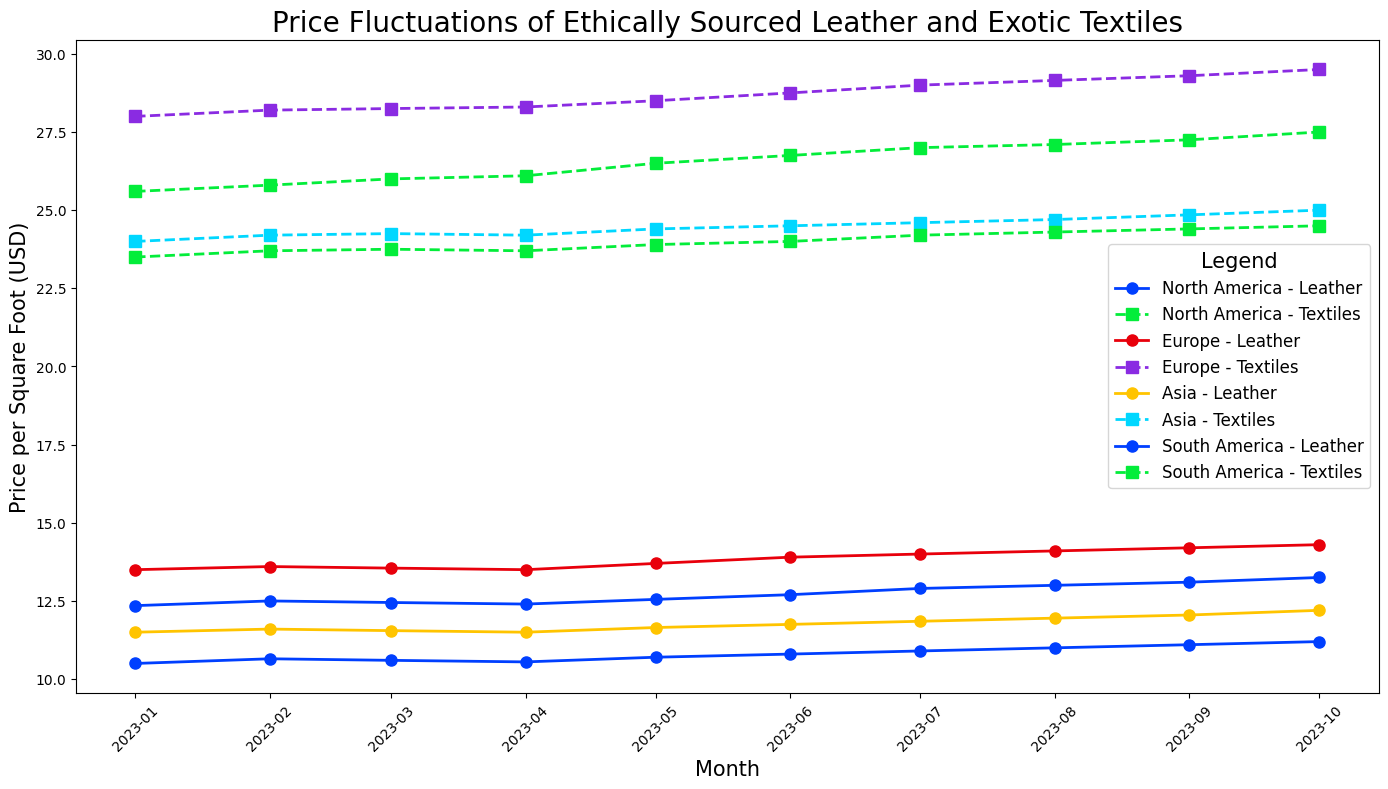Which region has the highest price for exotic textiles in October 2023? First, look at the data points in October 2023 for all regions for exotic textiles prices. Then, compare the values. Europe has the highest price of 29.50 USD per square foot.
Answer: Europe How much did the price of ethically sourced leather increase from January to October 2023 in North America? Identify the prices for January and October 2023 in North America for ethically sourced leather. Calculate the difference: 13.25 - 12.35 = 0.90 USD.
Answer: 0.90 USD Which region showed the most steady increase in the price of exotic textiles over the period? Examine the trend lines for exotic textiles in all regions and identify which one shows a consistent upward trend without any declines. Europe has a steady and consistent increase.
Answer: Europe On average, which region experienced the highest price for ethically sourced leather over the 10 months? Calculate the average price for each region by summing monthly prices and dividing by 10:
- North America: (12.35 + 12.50 + ... + 13.25) / 10 = 12.685 USD
- Europe: (13.50 + 13.60 + ... + 14.30) / 10 = 13.935 USD
- Asia: (11.50 + 11.60 + ... + 12.20) / 10 = 11.815 USD
- South America: (10.50 + 10.65 + ... + 11.20) / 10 = 10.82 USD
Europe has the highest average price of 13.935 USD.
Answer: Europe Did the price of exotic textiles in South America ever surpass the price of ethically sourced leather in the same region? Compare the monthly prices of exotic textiles with ethically sourced leather in South America. In every month, the price of exotic textiles is higher than ethically sourced leather.
Answer: Yes In which month did North America see the largest monthly increase in ethically sourced leather prices? Calculate the monthly changes and identify the month with the largest increase:
- February: 12.50 - 12.35 = 0.15 USD
- May: 12.55 - 12.40 = 0.15 USD
- June: 12.70 - 12.55 = 0.15 USD
- July: 12.90 - 12.70 = 0.20 USD
- October: 13.25 - 13.10 = 0.15 USD
July has the largest monthly increase of 0.20 USD.
Answer: July What was the combined price of exotic textiles and ethically sourced leather in Asia in August 2023? Add the prices of exotic textiles and ethically sourced leather for Asia in August 2023: 24.70 + 11.95 = 36.65 USD.
Answer: 36.65 USD Which month had the lowest price for exotic textiles in any region, and which region was it? Examine the data points for the lowest price across all months and regions. January 2023 in South America had the lowest price of 23.50 USD.
Answer: January 2023, South America How many months did the price of exotic textiles in Europe remain above 28 USD? Count the number of months where Europe’s exotic textiles price is above 28 USD. From January to October, all months have prices ranging from 28.00 to 29.50. Therefore, all 10 months fit the criteria.
Answer: 10 months 